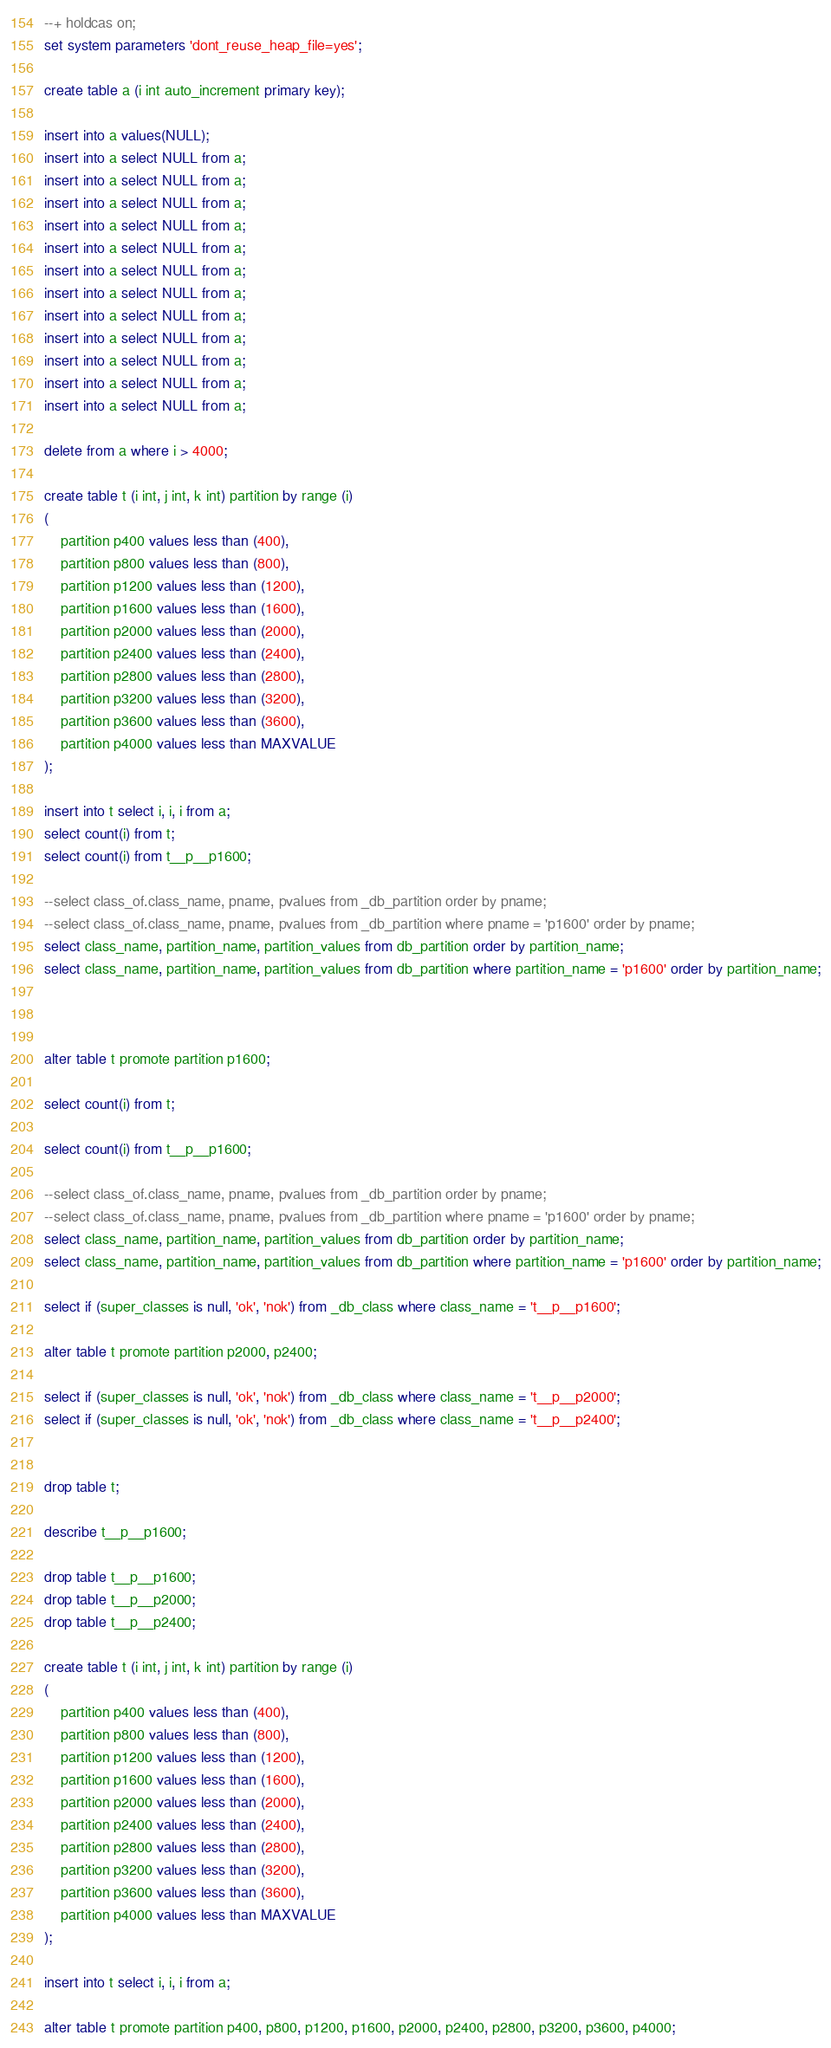Convert code to text. <code><loc_0><loc_0><loc_500><loc_500><_SQL_>--+ holdcas on;
set system parameters 'dont_reuse_heap_file=yes';

create table a (i int auto_increment primary key);

insert into a values(NULL);
insert into a select NULL from a;
insert into a select NULL from a;
insert into a select NULL from a;
insert into a select NULL from a;
insert into a select NULL from a;
insert into a select NULL from a;
insert into a select NULL from a;
insert into a select NULL from a;
insert into a select NULL from a;
insert into a select NULL from a;
insert into a select NULL from a;
insert into a select NULL from a;

delete from a where i > 4000;

create table t (i int, j int, k int) partition by range (i) 
(
	partition p400 values less than (400),
	partition p800 values less than (800),
	partition p1200 values less than (1200),
	partition p1600 values less than (1600),
	partition p2000 values less than (2000),
	partition p2400 values less than (2400),
	partition p2800 values less than (2800),
	partition p3200 values less than (3200),
	partition p3600 values less than (3600),
	partition p4000 values less than MAXVALUE
);

insert into t select i, i, i from a;
select count(i) from t;
select count(i) from t__p__p1600;

--select class_of.class_name, pname, pvalues from _db_partition order by pname;
--select class_of.class_name, pname, pvalues from _db_partition where pname = 'p1600' order by pname;
select class_name, partition_name, partition_values from db_partition order by partition_name;
select class_name, partition_name, partition_values from db_partition where partition_name = 'p1600' order by partition_name;



alter table t promote partition p1600;

select count(i) from t;

select count(i) from t__p__p1600;

--select class_of.class_name, pname, pvalues from _db_partition order by pname;
--select class_of.class_name, pname, pvalues from _db_partition where pname = 'p1600' order by pname;
select class_name, partition_name, partition_values from db_partition order by partition_name;
select class_name, partition_name, partition_values from db_partition where partition_name = 'p1600' order by partition_name;

select if (super_classes is null, 'ok', 'nok') from _db_class where class_name = 't__p__p1600';

alter table t promote partition p2000, p2400;

select if (super_classes is null, 'ok', 'nok') from _db_class where class_name = 't__p__p2000';
select if (super_classes is null, 'ok', 'nok') from _db_class where class_name = 't__p__p2400';


drop table t;

describe t__p__p1600;

drop table t__p__p1600;
drop table t__p__p2000;
drop table t__p__p2400;

create table t (i int, j int, k int) partition by range (i) 
(
	partition p400 values less than (400),
	partition p800 values less than (800),
	partition p1200 values less than (1200),
	partition p1600 values less than (1600),
	partition p2000 values less than (2000),
	partition p2400 values less than (2400),
	partition p2800 values less than (2800),
	partition p3200 values less than (3200),
	partition p3600 values less than (3600),
	partition p4000 values less than MAXVALUE
);

insert into t select i, i, i from a;

alter table t promote partition p400, p800, p1200, p1600, p2000, p2400, p2800, p3200, p3600, p4000;
</code> 